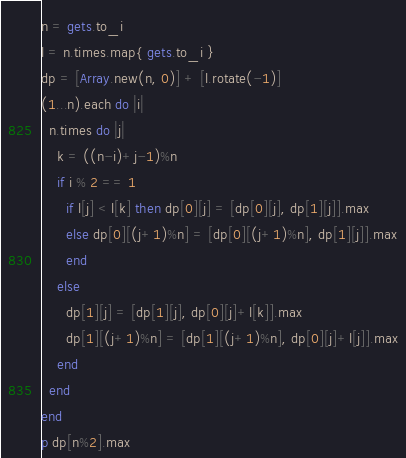Convert code to text. <code><loc_0><loc_0><loc_500><loc_500><_Ruby_>n = gets.to_i
l = n.times.map{ gets.to_i }
dp = [Array.new(n, 0)] + [l.rotate(-1)]
(1...n).each do |i|
  n.times do |j|
    k = ((n-i)+j-1)%n
    if i % 2 == 1
      if l[j] < l[k] then dp[0][j] = [dp[0][j], dp[1][j]].max
      else dp[0][(j+1)%n] = [dp[0][(j+1)%n], dp[1][j]].max
      end
    else
      dp[1][j] = [dp[1][j], dp[0][j]+l[k]].max
      dp[1][(j+1)%n] = [dp[1][(j+1)%n], dp[0][j]+l[j]].max
    end
  end
end
p dp[n%2].max</code> 